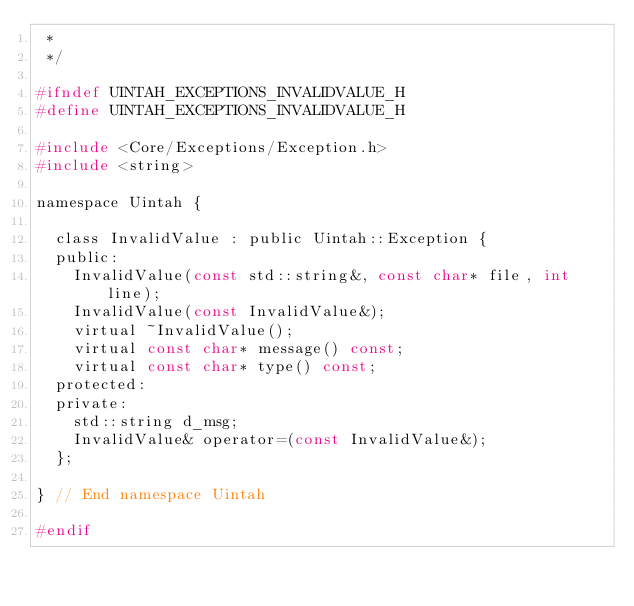<code> <loc_0><loc_0><loc_500><loc_500><_C_> *
 */

#ifndef UINTAH_EXCEPTIONS_INVALIDVALUE_H
#define UINTAH_EXCEPTIONS_INVALIDVALUE_H

#include <Core/Exceptions/Exception.h>
#include <string>

namespace Uintah {

  class InvalidValue : public Uintah::Exception {
  public:
    InvalidValue(const std::string&, const char* file, int line);
    InvalidValue(const InvalidValue&);
    virtual ~InvalidValue();
    virtual const char* message() const;
    virtual const char* type() const;
  protected:
  private:
    std::string d_msg;
    InvalidValue& operator=(const InvalidValue&);
  };

} // End namespace Uintah

#endif
</code> 